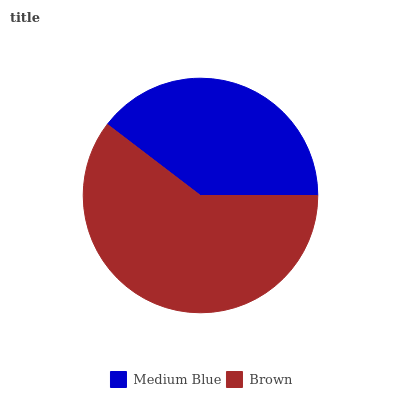Is Medium Blue the minimum?
Answer yes or no. Yes. Is Brown the maximum?
Answer yes or no. Yes. Is Brown the minimum?
Answer yes or no. No. Is Brown greater than Medium Blue?
Answer yes or no. Yes. Is Medium Blue less than Brown?
Answer yes or no. Yes. Is Medium Blue greater than Brown?
Answer yes or no. No. Is Brown less than Medium Blue?
Answer yes or no. No. Is Brown the high median?
Answer yes or no. Yes. Is Medium Blue the low median?
Answer yes or no. Yes. Is Medium Blue the high median?
Answer yes or no. No. Is Brown the low median?
Answer yes or no. No. 